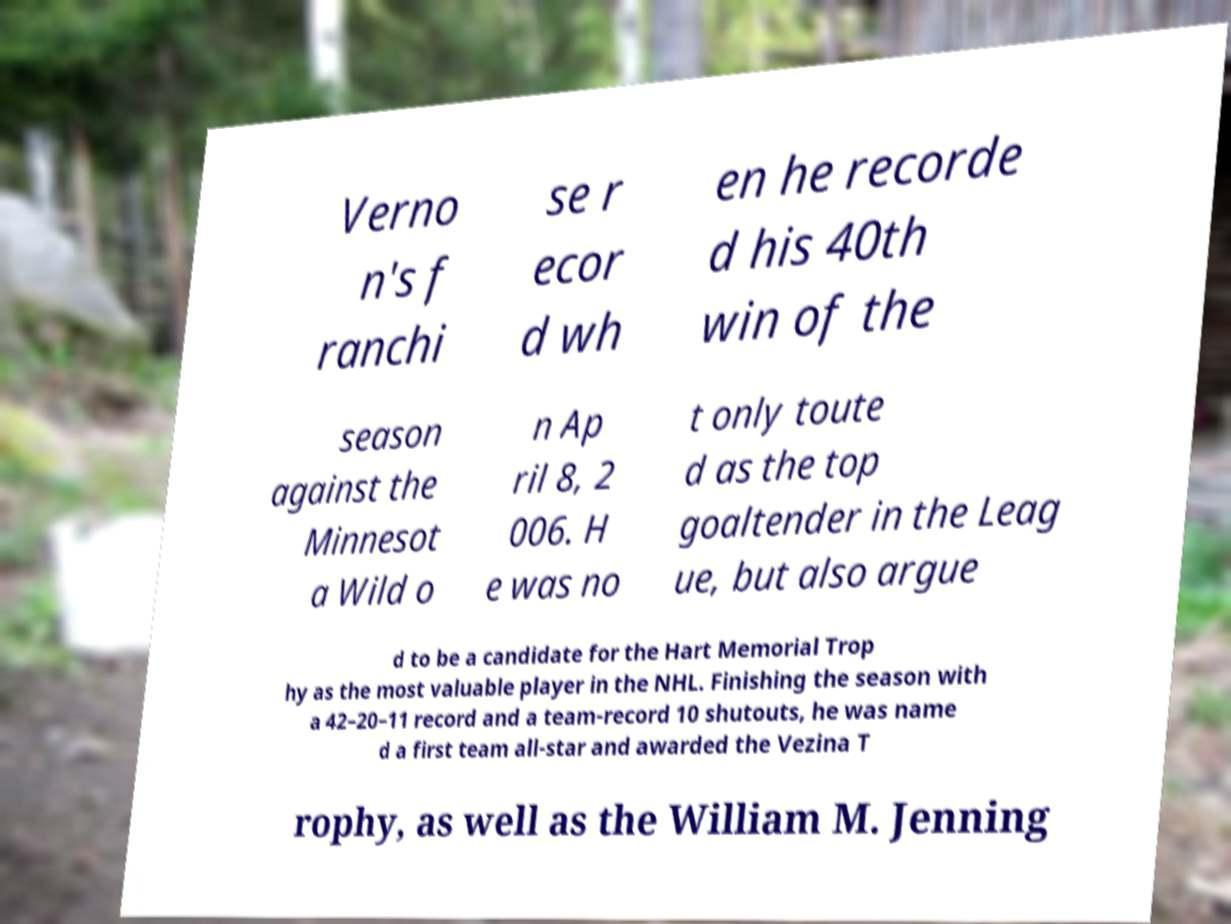Could you assist in decoding the text presented in this image and type it out clearly? Verno n's f ranchi se r ecor d wh en he recorde d his 40th win of the season against the Minnesot a Wild o n Ap ril 8, 2 006. H e was no t only toute d as the top goaltender in the Leag ue, but also argue d to be a candidate for the Hart Memorial Trop hy as the most valuable player in the NHL. Finishing the season with a 42–20–11 record and a team-record 10 shutouts, he was name d a first team all-star and awarded the Vezina T rophy, as well as the William M. Jenning 